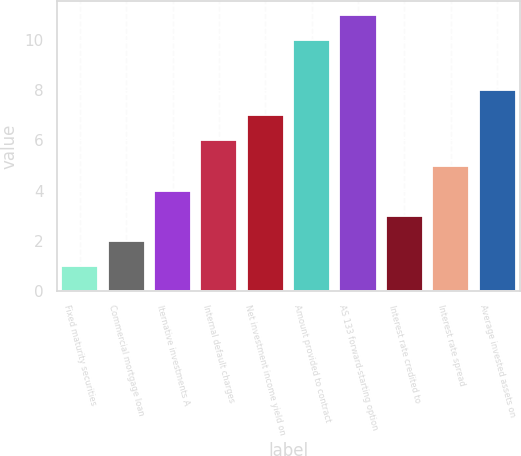Convert chart. <chart><loc_0><loc_0><loc_500><loc_500><bar_chart><fcel>Fixed maturity securities<fcel>Commercial mortgage loan<fcel>lternative investments A<fcel>Internal default charges<fcel>Net investment income yield on<fcel>Amount provided to contract<fcel>AS 133 forward-starting option<fcel>Interest rate credited to<fcel>Interest rate spread<fcel>Average invested assets on<nl><fcel>1<fcel>2<fcel>4<fcel>6<fcel>7<fcel>10<fcel>11<fcel>3<fcel>5<fcel>8<nl></chart> 